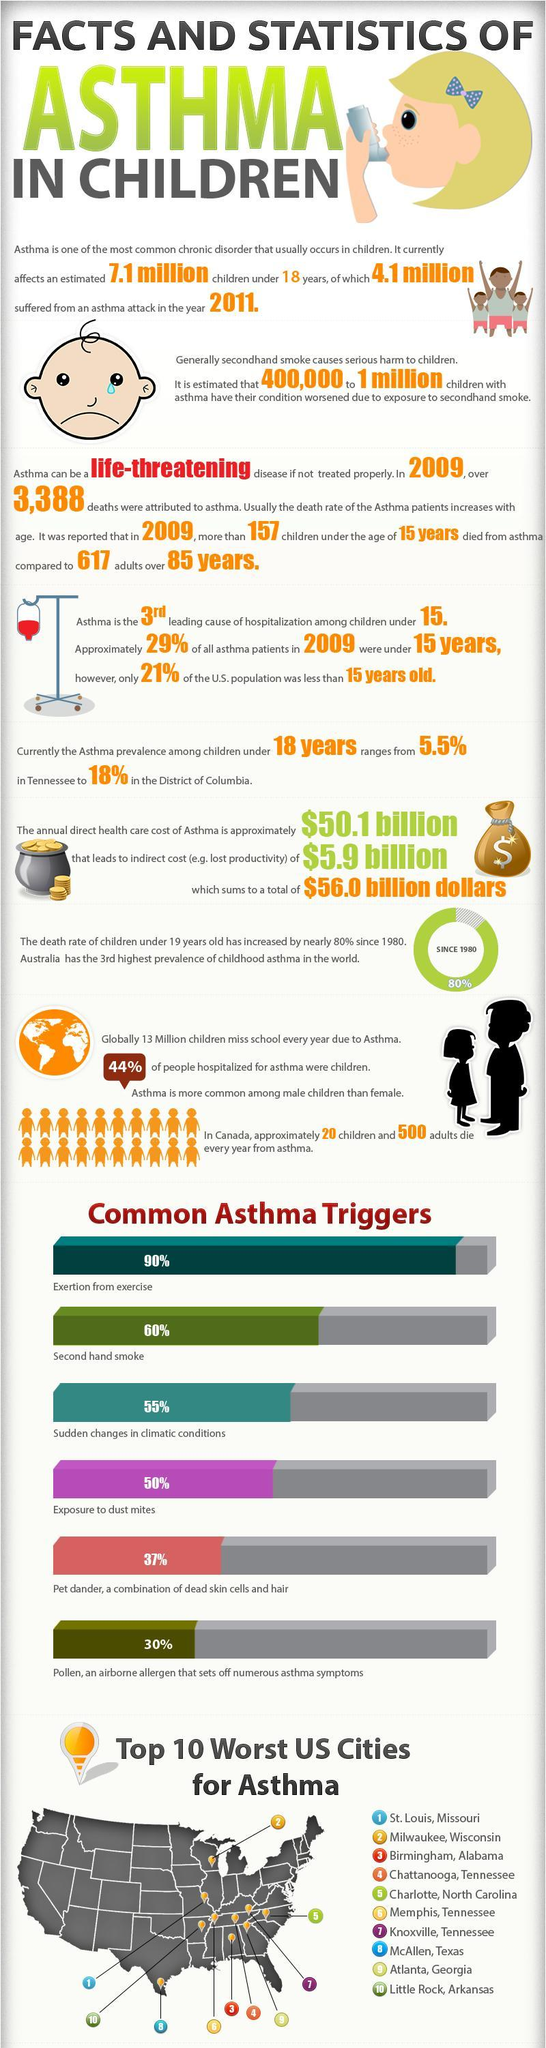What percentage of people hospitalized for asthma were not children?
Answer the question with a short phrase. 56% What is the percentage of asthma from second-hand shake And exertion from exercise? 150% What is the percentage of asthma from second-hand shake And exposure to dust mites? 110% 